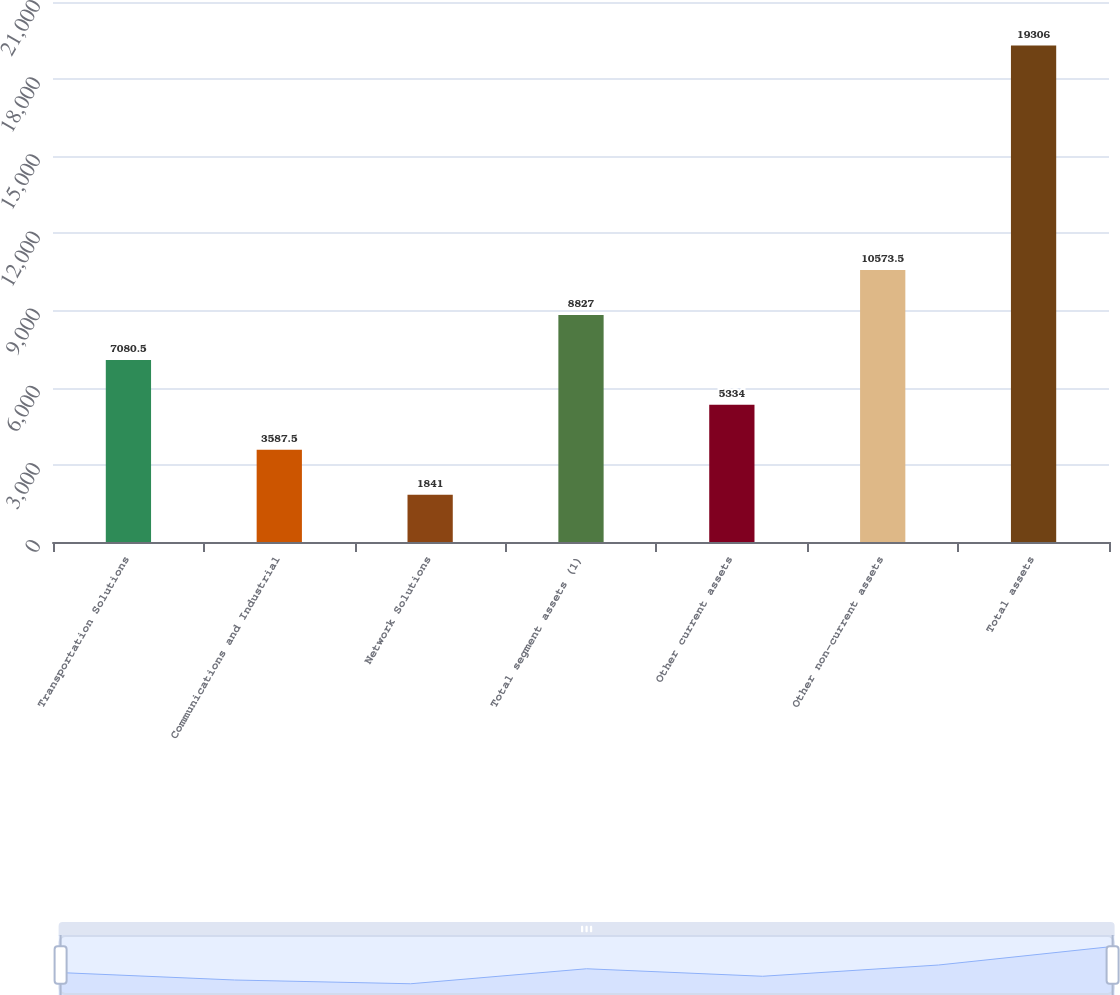<chart> <loc_0><loc_0><loc_500><loc_500><bar_chart><fcel>Transportation Solutions<fcel>Communications and Industrial<fcel>Network Solutions<fcel>Total segment assets (1)<fcel>Other current assets<fcel>Other non-current assets<fcel>Total assets<nl><fcel>7080.5<fcel>3587.5<fcel>1841<fcel>8827<fcel>5334<fcel>10573.5<fcel>19306<nl></chart> 